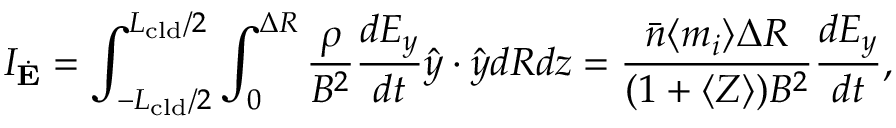<formula> <loc_0><loc_0><loc_500><loc_500>I _ { \dot { E } } = \int _ { - L _ { c l d } / 2 } ^ { L _ { c l d } / 2 } \int _ { 0 } ^ { \Delta R } \frac { \rho } { B ^ { 2 } } \frac { d E _ { y } } { d t } \hat { y } \cdot \hat { y } d R d z = \frac { \bar { n } \langle m _ { i } \rangle \Delta R } { ( 1 + \langle Z \rangle ) B ^ { 2 } } \frac { d E _ { y } } { d t } ,</formula> 